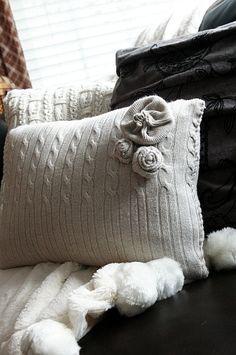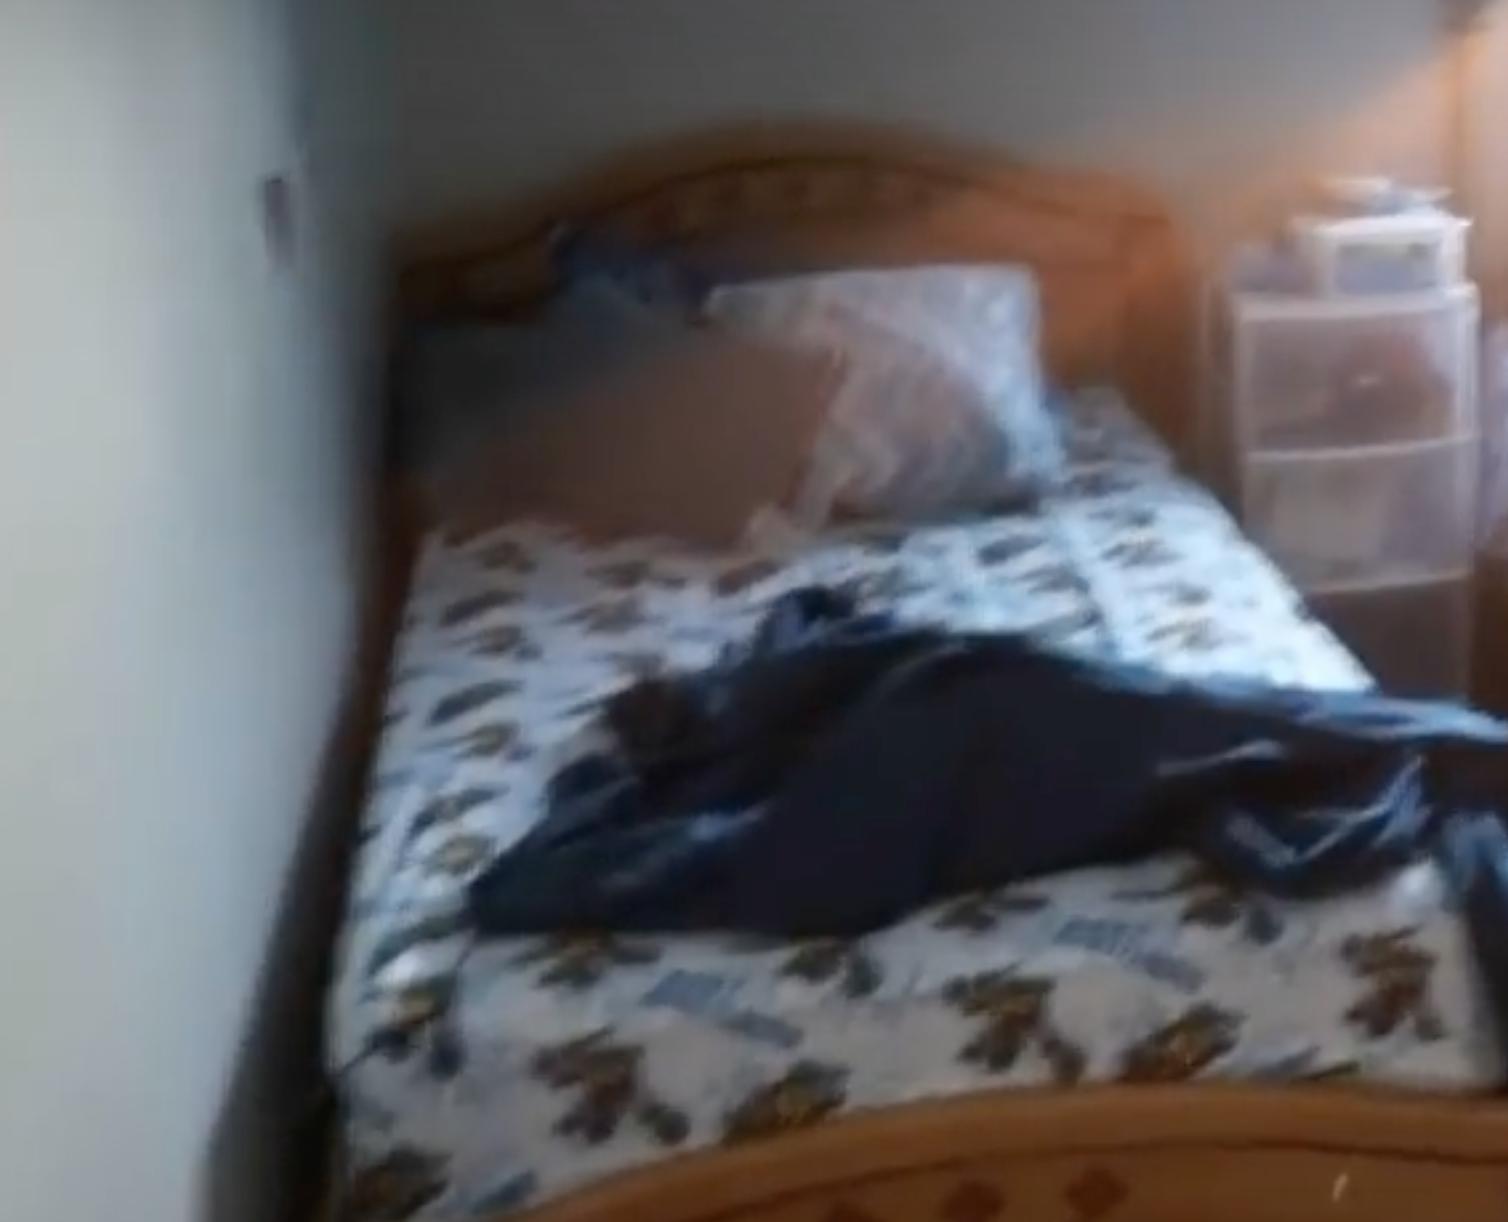The first image is the image on the left, the second image is the image on the right. Examine the images to the left and right. Is the description "There are at least six pillows in the image on the right" accurate? Answer yes or no. No. The first image is the image on the left, the second image is the image on the right. Analyze the images presented: Is the assertion "A image shows a pillow with a 3D embellishment." valid? Answer yes or no. Yes. 